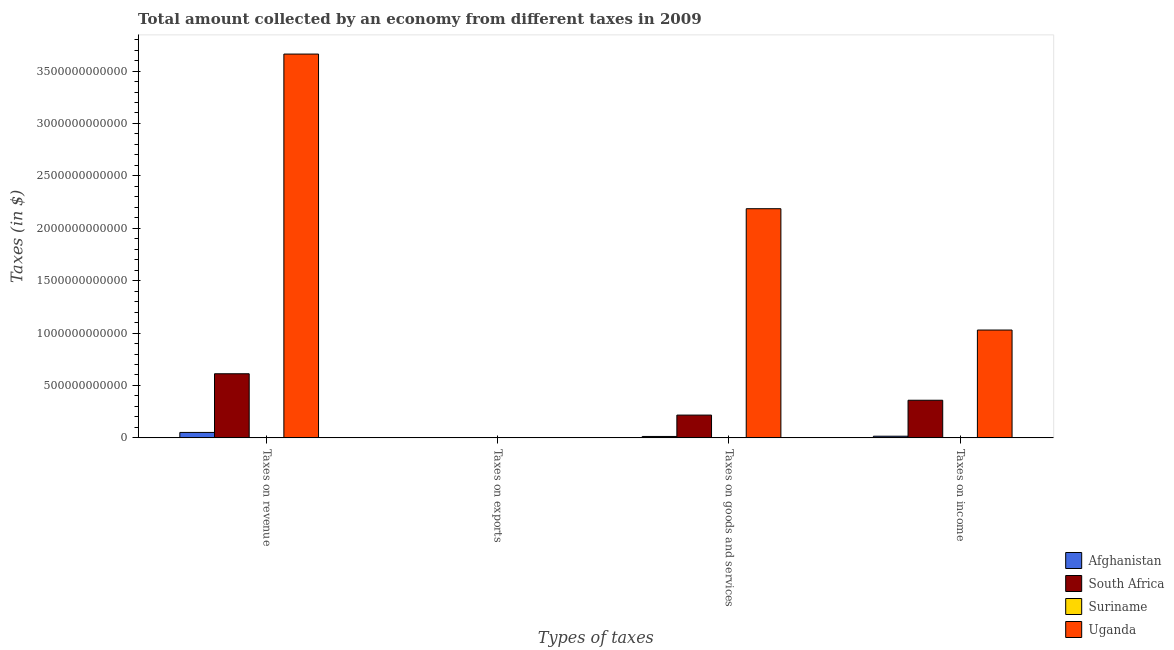How many different coloured bars are there?
Your response must be concise. 4. Are the number of bars per tick equal to the number of legend labels?
Keep it short and to the point. Yes. How many bars are there on the 3rd tick from the right?
Make the answer very short. 4. What is the label of the 3rd group of bars from the left?
Ensure brevity in your answer.  Taxes on goods and services. What is the amount collected as tax on exports in Afghanistan?
Give a very brief answer. 9.03e+06. Across all countries, what is the maximum amount collected as tax on exports?
Ensure brevity in your answer.  1.14e+09. Across all countries, what is the minimum amount collected as tax on income?
Provide a short and direct response. 7.49e+08. In which country was the amount collected as tax on goods maximum?
Make the answer very short. Uganda. In which country was the amount collected as tax on exports minimum?
Offer a terse response. Suriname. What is the total amount collected as tax on goods in the graph?
Keep it short and to the point. 2.42e+12. What is the difference between the amount collected as tax on goods in Suriname and that in Afghanistan?
Provide a succinct answer. -1.28e+1. What is the difference between the amount collected as tax on exports in South Africa and the amount collected as tax on income in Suriname?
Give a very brief answer. -7.13e+08. What is the average amount collected as tax on exports per country?
Offer a terse response. 2.96e+08. What is the difference between the amount collected as tax on income and amount collected as tax on revenue in South Africa?
Ensure brevity in your answer.  -2.53e+11. In how many countries, is the amount collected as tax on income greater than 400000000000 $?
Give a very brief answer. 1. What is the ratio of the amount collected as tax on income in Suriname to that in South Africa?
Ensure brevity in your answer.  0. Is the amount collected as tax on goods in Uganda less than that in Afghanistan?
Provide a short and direct response. No. What is the difference between the highest and the second highest amount collected as tax on revenue?
Your response must be concise. 3.05e+12. What is the difference between the highest and the lowest amount collected as tax on revenue?
Provide a short and direct response. 3.66e+12. In how many countries, is the amount collected as tax on goods greater than the average amount collected as tax on goods taken over all countries?
Keep it short and to the point. 1. Is the sum of the amount collected as tax on revenue in Uganda and Afghanistan greater than the maximum amount collected as tax on income across all countries?
Your response must be concise. Yes. Is it the case that in every country, the sum of the amount collected as tax on income and amount collected as tax on goods is greater than the sum of amount collected as tax on revenue and amount collected as tax on exports?
Your answer should be compact. Yes. What does the 2nd bar from the left in Taxes on exports represents?
Your answer should be compact. South Africa. What does the 2nd bar from the right in Taxes on goods and services represents?
Give a very brief answer. Suriname. Is it the case that in every country, the sum of the amount collected as tax on revenue and amount collected as tax on exports is greater than the amount collected as tax on goods?
Give a very brief answer. Yes. How many countries are there in the graph?
Offer a very short reply. 4. What is the difference between two consecutive major ticks on the Y-axis?
Your answer should be compact. 5.00e+11. Does the graph contain any zero values?
Offer a terse response. No. Does the graph contain grids?
Your answer should be very brief. No. Where does the legend appear in the graph?
Your response must be concise. Bottom right. How many legend labels are there?
Offer a very short reply. 4. What is the title of the graph?
Your response must be concise. Total amount collected by an economy from different taxes in 2009. What is the label or title of the X-axis?
Give a very brief answer. Types of taxes. What is the label or title of the Y-axis?
Offer a terse response. Taxes (in $). What is the Taxes (in $) in Afghanistan in Taxes on revenue?
Your answer should be compact. 5.19e+1. What is the Taxes (in $) of South Africa in Taxes on revenue?
Offer a terse response. 6.12e+11. What is the Taxes (in $) in Suriname in Taxes on revenue?
Give a very brief answer. 1.83e+09. What is the Taxes (in $) in Uganda in Taxes on revenue?
Offer a very short reply. 3.66e+12. What is the Taxes (in $) of Afghanistan in Taxes on exports?
Ensure brevity in your answer.  9.03e+06. What is the Taxes (in $) of South Africa in Taxes on exports?
Make the answer very short. 3.60e+07. What is the Taxes (in $) of Suriname in Taxes on exports?
Ensure brevity in your answer.  4.27e+06. What is the Taxes (in $) in Uganda in Taxes on exports?
Provide a succinct answer. 1.14e+09. What is the Taxes (in $) of Afghanistan in Taxes on goods and services?
Your answer should be very brief. 1.35e+1. What is the Taxes (in $) in South Africa in Taxes on goods and services?
Provide a succinct answer. 2.17e+11. What is the Taxes (in $) in Suriname in Taxes on goods and services?
Give a very brief answer. 7.38e+08. What is the Taxes (in $) of Uganda in Taxes on goods and services?
Offer a very short reply. 2.19e+12. What is the Taxes (in $) of Afghanistan in Taxes on income?
Your answer should be very brief. 1.58e+1. What is the Taxes (in $) in South Africa in Taxes on income?
Offer a terse response. 3.59e+11. What is the Taxes (in $) in Suriname in Taxes on income?
Offer a very short reply. 7.49e+08. What is the Taxes (in $) in Uganda in Taxes on income?
Offer a very short reply. 1.03e+12. Across all Types of taxes, what is the maximum Taxes (in $) of Afghanistan?
Provide a succinct answer. 5.19e+1. Across all Types of taxes, what is the maximum Taxes (in $) of South Africa?
Ensure brevity in your answer.  6.12e+11. Across all Types of taxes, what is the maximum Taxes (in $) of Suriname?
Give a very brief answer. 1.83e+09. Across all Types of taxes, what is the maximum Taxes (in $) of Uganda?
Give a very brief answer. 3.66e+12. Across all Types of taxes, what is the minimum Taxes (in $) in Afghanistan?
Make the answer very short. 9.03e+06. Across all Types of taxes, what is the minimum Taxes (in $) of South Africa?
Make the answer very short. 3.60e+07. Across all Types of taxes, what is the minimum Taxes (in $) of Suriname?
Keep it short and to the point. 4.27e+06. Across all Types of taxes, what is the minimum Taxes (in $) of Uganda?
Keep it short and to the point. 1.14e+09. What is the total Taxes (in $) in Afghanistan in the graph?
Your response must be concise. 8.12e+1. What is the total Taxes (in $) in South Africa in the graph?
Offer a terse response. 1.19e+12. What is the total Taxes (in $) in Suriname in the graph?
Your answer should be very brief. 3.32e+09. What is the total Taxes (in $) in Uganda in the graph?
Offer a terse response. 6.88e+12. What is the difference between the Taxes (in $) of Afghanistan in Taxes on revenue and that in Taxes on exports?
Ensure brevity in your answer.  5.19e+1. What is the difference between the Taxes (in $) of South Africa in Taxes on revenue and that in Taxes on exports?
Your response must be concise. 6.12e+11. What is the difference between the Taxes (in $) in Suriname in Taxes on revenue and that in Taxes on exports?
Offer a terse response. 1.83e+09. What is the difference between the Taxes (in $) of Uganda in Taxes on revenue and that in Taxes on exports?
Your answer should be very brief. 3.66e+12. What is the difference between the Taxes (in $) in Afghanistan in Taxes on revenue and that in Taxes on goods and services?
Offer a terse response. 3.84e+1. What is the difference between the Taxes (in $) of South Africa in Taxes on revenue and that in Taxes on goods and services?
Provide a short and direct response. 3.94e+11. What is the difference between the Taxes (in $) in Suriname in Taxes on revenue and that in Taxes on goods and services?
Offer a very short reply. 1.09e+09. What is the difference between the Taxes (in $) in Uganda in Taxes on revenue and that in Taxes on goods and services?
Your answer should be very brief. 1.48e+12. What is the difference between the Taxes (in $) in Afghanistan in Taxes on revenue and that in Taxes on income?
Provide a short and direct response. 3.60e+1. What is the difference between the Taxes (in $) in South Africa in Taxes on revenue and that in Taxes on income?
Keep it short and to the point. 2.53e+11. What is the difference between the Taxes (in $) of Suriname in Taxes on revenue and that in Taxes on income?
Your answer should be very brief. 1.08e+09. What is the difference between the Taxes (in $) in Uganda in Taxes on revenue and that in Taxes on income?
Ensure brevity in your answer.  2.63e+12. What is the difference between the Taxes (in $) of Afghanistan in Taxes on exports and that in Taxes on goods and services?
Make the answer very short. -1.35e+1. What is the difference between the Taxes (in $) of South Africa in Taxes on exports and that in Taxes on goods and services?
Offer a very short reply. -2.17e+11. What is the difference between the Taxes (in $) of Suriname in Taxes on exports and that in Taxes on goods and services?
Offer a very short reply. -7.33e+08. What is the difference between the Taxes (in $) in Uganda in Taxes on exports and that in Taxes on goods and services?
Give a very brief answer. -2.19e+12. What is the difference between the Taxes (in $) in Afghanistan in Taxes on exports and that in Taxes on income?
Make the answer very short. -1.58e+1. What is the difference between the Taxes (in $) of South Africa in Taxes on exports and that in Taxes on income?
Your answer should be compact. -3.59e+11. What is the difference between the Taxes (in $) in Suriname in Taxes on exports and that in Taxes on income?
Keep it short and to the point. -7.45e+08. What is the difference between the Taxes (in $) of Uganda in Taxes on exports and that in Taxes on income?
Give a very brief answer. -1.03e+12. What is the difference between the Taxes (in $) of Afghanistan in Taxes on goods and services and that in Taxes on income?
Offer a terse response. -2.34e+09. What is the difference between the Taxes (in $) of South Africa in Taxes on goods and services and that in Taxes on income?
Make the answer very short. -1.42e+11. What is the difference between the Taxes (in $) in Suriname in Taxes on goods and services and that in Taxes on income?
Give a very brief answer. -1.17e+07. What is the difference between the Taxes (in $) of Uganda in Taxes on goods and services and that in Taxes on income?
Give a very brief answer. 1.16e+12. What is the difference between the Taxes (in $) in Afghanistan in Taxes on revenue and the Taxes (in $) in South Africa in Taxes on exports?
Your answer should be very brief. 5.18e+1. What is the difference between the Taxes (in $) of Afghanistan in Taxes on revenue and the Taxes (in $) of Suriname in Taxes on exports?
Make the answer very short. 5.19e+1. What is the difference between the Taxes (in $) in Afghanistan in Taxes on revenue and the Taxes (in $) in Uganda in Taxes on exports?
Your response must be concise. 5.07e+1. What is the difference between the Taxes (in $) in South Africa in Taxes on revenue and the Taxes (in $) in Suriname in Taxes on exports?
Offer a very short reply. 6.12e+11. What is the difference between the Taxes (in $) in South Africa in Taxes on revenue and the Taxes (in $) in Uganda in Taxes on exports?
Provide a succinct answer. 6.11e+11. What is the difference between the Taxes (in $) in Suriname in Taxes on revenue and the Taxes (in $) in Uganda in Taxes on exports?
Make the answer very short. 6.95e+08. What is the difference between the Taxes (in $) in Afghanistan in Taxes on revenue and the Taxes (in $) in South Africa in Taxes on goods and services?
Provide a short and direct response. -1.65e+11. What is the difference between the Taxes (in $) of Afghanistan in Taxes on revenue and the Taxes (in $) of Suriname in Taxes on goods and services?
Your answer should be very brief. 5.11e+1. What is the difference between the Taxes (in $) of Afghanistan in Taxes on revenue and the Taxes (in $) of Uganda in Taxes on goods and services?
Provide a short and direct response. -2.13e+12. What is the difference between the Taxes (in $) of South Africa in Taxes on revenue and the Taxes (in $) of Suriname in Taxes on goods and services?
Make the answer very short. 6.11e+11. What is the difference between the Taxes (in $) in South Africa in Taxes on revenue and the Taxes (in $) in Uganda in Taxes on goods and services?
Keep it short and to the point. -1.57e+12. What is the difference between the Taxes (in $) of Suriname in Taxes on revenue and the Taxes (in $) of Uganda in Taxes on goods and services?
Keep it short and to the point. -2.18e+12. What is the difference between the Taxes (in $) of Afghanistan in Taxes on revenue and the Taxes (in $) of South Africa in Taxes on income?
Give a very brief answer. -3.07e+11. What is the difference between the Taxes (in $) in Afghanistan in Taxes on revenue and the Taxes (in $) in Suriname in Taxes on income?
Your answer should be very brief. 5.11e+1. What is the difference between the Taxes (in $) in Afghanistan in Taxes on revenue and the Taxes (in $) in Uganda in Taxes on income?
Ensure brevity in your answer.  -9.77e+11. What is the difference between the Taxes (in $) of South Africa in Taxes on revenue and the Taxes (in $) of Suriname in Taxes on income?
Make the answer very short. 6.11e+11. What is the difference between the Taxes (in $) in South Africa in Taxes on revenue and the Taxes (in $) in Uganda in Taxes on income?
Ensure brevity in your answer.  -4.17e+11. What is the difference between the Taxes (in $) in Suriname in Taxes on revenue and the Taxes (in $) in Uganda in Taxes on income?
Provide a succinct answer. -1.03e+12. What is the difference between the Taxes (in $) of Afghanistan in Taxes on exports and the Taxes (in $) of South Africa in Taxes on goods and services?
Your answer should be very brief. -2.17e+11. What is the difference between the Taxes (in $) of Afghanistan in Taxes on exports and the Taxes (in $) of Suriname in Taxes on goods and services?
Give a very brief answer. -7.29e+08. What is the difference between the Taxes (in $) in Afghanistan in Taxes on exports and the Taxes (in $) in Uganda in Taxes on goods and services?
Make the answer very short. -2.19e+12. What is the difference between the Taxes (in $) in South Africa in Taxes on exports and the Taxes (in $) in Suriname in Taxes on goods and services?
Ensure brevity in your answer.  -7.02e+08. What is the difference between the Taxes (in $) of South Africa in Taxes on exports and the Taxes (in $) of Uganda in Taxes on goods and services?
Offer a very short reply. -2.19e+12. What is the difference between the Taxes (in $) of Suriname in Taxes on exports and the Taxes (in $) of Uganda in Taxes on goods and services?
Offer a terse response. -2.19e+12. What is the difference between the Taxes (in $) of Afghanistan in Taxes on exports and the Taxes (in $) of South Africa in Taxes on income?
Provide a succinct answer. -3.59e+11. What is the difference between the Taxes (in $) in Afghanistan in Taxes on exports and the Taxes (in $) in Suriname in Taxes on income?
Provide a succinct answer. -7.40e+08. What is the difference between the Taxes (in $) in Afghanistan in Taxes on exports and the Taxes (in $) in Uganda in Taxes on income?
Make the answer very short. -1.03e+12. What is the difference between the Taxes (in $) in South Africa in Taxes on exports and the Taxes (in $) in Suriname in Taxes on income?
Your response must be concise. -7.13e+08. What is the difference between the Taxes (in $) of South Africa in Taxes on exports and the Taxes (in $) of Uganda in Taxes on income?
Ensure brevity in your answer.  -1.03e+12. What is the difference between the Taxes (in $) of Suriname in Taxes on exports and the Taxes (in $) of Uganda in Taxes on income?
Provide a short and direct response. -1.03e+12. What is the difference between the Taxes (in $) in Afghanistan in Taxes on goods and services and the Taxes (in $) in South Africa in Taxes on income?
Give a very brief answer. -3.46e+11. What is the difference between the Taxes (in $) of Afghanistan in Taxes on goods and services and the Taxes (in $) of Suriname in Taxes on income?
Offer a very short reply. 1.27e+1. What is the difference between the Taxes (in $) of Afghanistan in Taxes on goods and services and the Taxes (in $) of Uganda in Taxes on income?
Offer a terse response. -1.02e+12. What is the difference between the Taxes (in $) of South Africa in Taxes on goods and services and the Taxes (in $) of Suriname in Taxes on income?
Offer a terse response. 2.17e+11. What is the difference between the Taxes (in $) in South Africa in Taxes on goods and services and the Taxes (in $) in Uganda in Taxes on income?
Your response must be concise. -8.12e+11. What is the difference between the Taxes (in $) in Suriname in Taxes on goods and services and the Taxes (in $) in Uganda in Taxes on income?
Give a very brief answer. -1.03e+12. What is the average Taxes (in $) of Afghanistan per Types of taxes?
Provide a succinct answer. 2.03e+1. What is the average Taxes (in $) in South Africa per Types of taxes?
Your response must be concise. 2.97e+11. What is the average Taxes (in $) of Suriname per Types of taxes?
Your answer should be compact. 8.31e+08. What is the average Taxes (in $) in Uganda per Types of taxes?
Give a very brief answer. 1.72e+12. What is the difference between the Taxes (in $) in Afghanistan and Taxes (in $) in South Africa in Taxes on revenue?
Give a very brief answer. -5.60e+11. What is the difference between the Taxes (in $) in Afghanistan and Taxes (in $) in Suriname in Taxes on revenue?
Offer a very short reply. 5.01e+1. What is the difference between the Taxes (in $) of Afghanistan and Taxes (in $) of Uganda in Taxes on revenue?
Your answer should be compact. -3.61e+12. What is the difference between the Taxes (in $) of South Africa and Taxes (in $) of Suriname in Taxes on revenue?
Your answer should be compact. 6.10e+11. What is the difference between the Taxes (in $) of South Africa and Taxes (in $) of Uganda in Taxes on revenue?
Offer a very short reply. -3.05e+12. What is the difference between the Taxes (in $) in Suriname and Taxes (in $) in Uganda in Taxes on revenue?
Offer a terse response. -3.66e+12. What is the difference between the Taxes (in $) of Afghanistan and Taxes (in $) of South Africa in Taxes on exports?
Your answer should be compact. -2.70e+07. What is the difference between the Taxes (in $) of Afghanistan and Taxes (in $) of Suriname in Taxes on exports?
Your answer should be very brief. 4.75e+06. What is the difference between the Taxes (in $) of Afghanistan and Taxes (in $) of Uganda in Taxes on exports?
Offer a very short reply. -1.13e+09. What is the difference between the Taxes (in $) of South Africa and Taxes (in $) of Suriname in Taxes on exports?
Ensure brevity in your answer.  3.17e+07. What is the difference between the Taxes (in $) in South Africa and Taxes (in $) in Uganda in Taxes on exports?
Give a very brief answer. -1.10e+09. What is the difference between the Taxes (in $) in Suriname and Taxes (in $) in Uganda in Taxes on exports?
Offer a terse response. -1.13e+09. What is the difference between the Taxes (in $) in Afghanistan and Taxes (in $) in South Africa in Taxes on goods and services?
Your answer should be very brief. -2.04e+11. What is the difference between the Taxes (in $) of Afghanistan and Taxes (in $) of Suriname in Taxes on goods and services?
Your answer should be very brief. 1.28e+1. What is the difference between the Taxes (in $) of Afghanistan and Taxes (in $) of Uganda in Taxes on goods and services?
Ensure brevity in your answer.  -2.17e+12. What is the difference between the Taxes (in $) of South Africa and Taxes (in $) of Suriname in Taxes on goods and services?
Give a very brief answer. 2.17e+11. What is the difference between the Taxes (in $) in South Africa and Taxes (in $) in Uganda in Taxes on goods and services?
Offer a very short reply. -1.97e+12. What is the difference between the Taxes (in $) in Suriname and Taxes (in $) in Uganda in Taxes on goods and services?
Provide a succinct answer. -2.19e+12. What is the difference between the Taxes (in $) of Afghanistan and Taxes (in $) of South Africa in Taxes on income?
Ensure brevity in your answer.  -3.43e+11. What is the difference between the Taxes (in $) of Afghanistan and Taxes (in $) of Suriname in Taxes on income?
Offer a terse response. 1.51e+1. What is the difference between the Taxes (in $) in Afghanistan and Taxes (in $) in Uganda in Taxes on income?
Give a very brief answer. -1.01e+12. What is the difference between the Taxes (in $) of South Africa and Taxes (in $) of Suriname in Taxes on income?
Offer a very short reply. 3.58e+11. What is the difference between the Taxes (in $) of South Africa and Taxes (in $) of Uganda in Taxes on income?
Your answer should be compact. -6.70e+11. What is the difference between the Taxes (in $) in Suriname and Taxes (in $) in Uganda in Taxes on income?
Ensure brevity in your answer.  -1.03e+12. What is the ratio of the Taxes (in $) of Afghanistan in Taxes on revenue to that in Taxes on exports?
Your response must be concise. 5748.5. What is the ratio of the Taxes (in $) of South Africa in Taxes on revenue to that in Taxes on exports?
Offer a very short reply. 1.70e+04. What is the ratio of the Taxes (in $) in Suriname in Taxes on revenue to that in Taxes on exports?
Your answer should be very brief. 428.91. What is the ratio of the Taxes (in $) of Uganda in Taxes on revenue to that in Taxes on exports?
Offer a terse response. 3222.37. What is the ratio of the Taxes (in $) in Afghanistan in Taxes on revenue to that in Taxes on goods and services?
Provide a short and direct response. 3.84. What is the ratio of the Taxes (in $) in South Africa in Taxes on revenue to that in Taxes on goods and services?
Make the answer very short. 2.81. What is the ratio of the Taxes (in $) in Suriname in Taxes on revenue to that in Taxes on goods and services?
Offer a terse response. 2.48. What is the ratio of the Taxes (in $) in Uganda in Taxes on revenue to that in Taxes on goods and services?
Your answer should be very brief. 1.67. What is the ratio of the Taxes (in $) in Afghanistan in Taxes on revenue to that in Taxes on income?
Offer a terse response. 3.28. What is the ratio of the Taxes (in $) in South Africa in Taxes on revenue to that in Taxes on income?
Offer a terse response. 1.7. What is the ratio of the Taxes (in $) in Suriname in Taxes on revenue to that in Taxes on income?
Keep it short and to the point. 2.44. What is the ratio of the Taxes (in $) in Uganda in Taxes on revenue to that in Taxes on income?
Ensure brevity in your answer.  3.56. What is the ratio of the Taxes (in $) in Afghanistan in Taxes on exports to that in Taxes on goods and services?
Your answer should be very brief. 0. What is the ratio of the Taxes (in $) of Suriname in Taxes on exports to that in Taxes on goods and services?
Your answer should be very brief. 0.01. What is the ratio of the Taxes (in $) in Uganda in Taxes on exports to that in Taxes on goods and services?
Keep it short and to the point. 0. What is the ratio of the Taxes (in $) in Afghanistan in Taxes on exports to that in Taxes on income?
Keep it short and to the point. 0. What is the ratio of the Taxes (in $) of South Africa in Taxes on exports to that in Taxes on income?
Your answer should be very brief. 0. What is the ratio of the Taxes (in $) in Suriname in Taxes on exports to that in Taxes on income?
Your answer should be compact. 0.01. What is the ratio of the Taxes (in $) in Uganda in Taxes on exports to that in Taxes on income?
Your response must be concise. 0. What is the ratio of the Taxes (in $) of Afghanistan in Taxes on goods and services to that in Taxes on income?
Make the answer very short. 0.85. What is the ratio of the Taxes (in $) in South Africa in Taxes on goods and services to that in Taxes on income?
Make the answer very short. 0.61. What is the ratio of the Taxes (in $) in Suriname in Taxes on goods and services to that in Taxes on income?
Keep it short and to the point. 0.98. What is the ratio of the Taxes (in $) of Uganda in Taxes on goods and services to that in Taxes on income?
Offer a very short reply. 2.13. What is the difference between the highest and the second highest Taxes (in $) in Afghanistan?
Make the answer very short. 3.60e+1. What is the difference between the highest and the second highest Taxes (in $) of South Africa?
Provide a succinct answer. 2.53e+11. What is the difference between the highest and the second highest Taxes (in $) in Suriname?
Keep it short and to the point. 1.08e+09. What is the difference between the highest and the second highest Taxes (in $) in Uganda?
Offer a terse response. 1.48e+12. What is the difference between the highest and the lowest Taxes (in $) in Afghanistan?
Your response must be concise. 5.19e+1. What is the difference between the highest and the lowest Taxes (in $) in South Africa?
Your response must be concise. 6.12e+11. What is the difference between the highest and the lowest Taxes (in $) in Suriname?
Your answer should be very brief. 1.83e+09. What is the difference between the highest and the lowest Taxes (in $) of Uganda?
Offer a very short reply. 3.66e+12. 